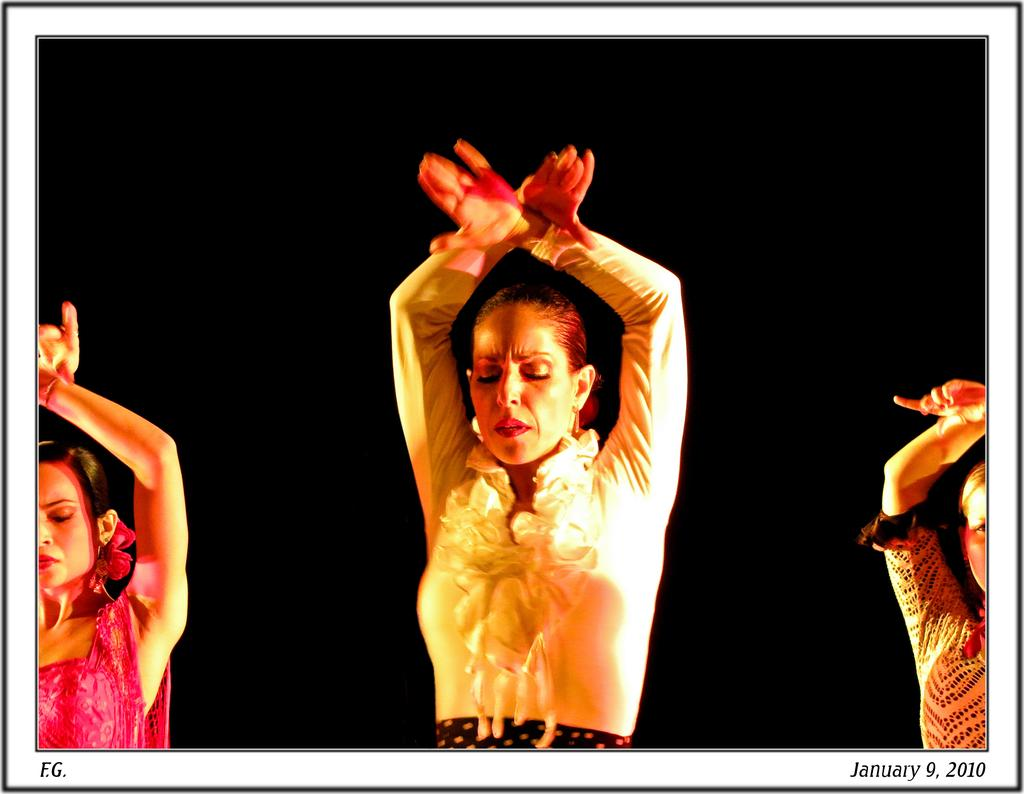How many people are in the image? There are three women in the image. Can you describe any specific features or characteristics of the image? Yes, there are watermarks at the bottom of the image. What type of stew is being prepared by the women in the image? There is no indication in the image that the women are preparing any stew, as the image only shows three women and watermarks at the bottom. 